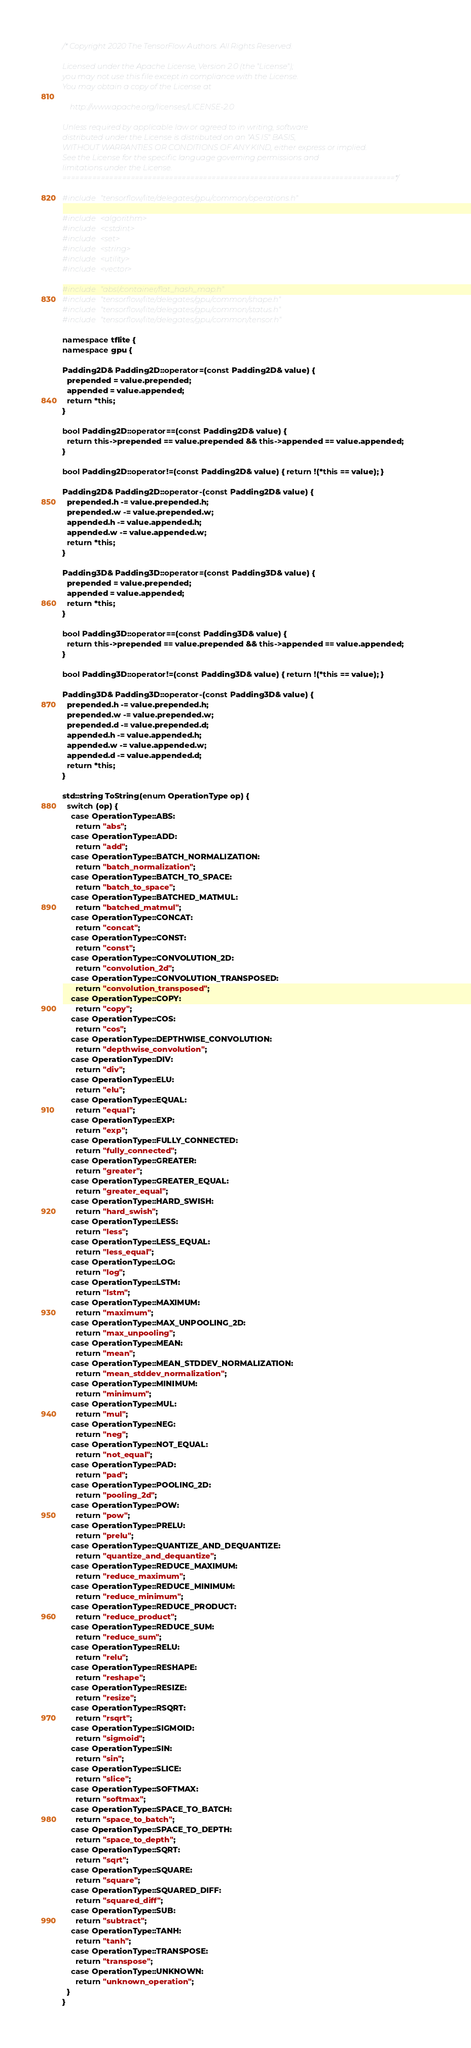Convert code to text. <code><loc_0><loc_0><loc_500><loc_500><_C++_>/* Copyright 2020 The TensorFlow Authors. All Rights Reserved.

Licensed under the Apache License, Version 2.0 (the "License");
you may not use this file except in compliance with the License.
You may obtain a copy of the License at

    http://www.apache.org/licenses/LICENSE-2.0

Unless required by applicable law or agreed to in writing, software
distributed under the License is distributed on an "AS IS" BASIS,
WITHOUT WARRANTIES OR CONDITIONS OF ANY KIND, either express or implied.
See the License for the specific language governing permissions and
limitations under the License.
==============================================================================*/

#include "tensorflow/lite/delegates/gpu/common/operations.h"

#include <algorithm>
#include <cstdint>
#include <set>
#include <string>
#include <utility>
#include <vector>

#include "absl/container/flat_hash_map.h"
#include "tensorflow/lite/delegates/gpu/common/shape.h"
#include "tensorflow/lite/delegates/gpu/common/status.h"
#include "tensorflow/lite/delegates/gpu/common/tensor.h"

namespace tflite {
namespace gpu {

Padding2D& Padding2D::operator=(const Padding2D& value) {
  prepended = value.prepended;
  appended = value.appended;
  return *this;
}

bool Padding2D::operator==(const Padding2D& value) {
  return this->prepended == value.prepended && this->appended == value.appended;
}

bool Padding2D::operator!=(const Padding2D& value) { return !(*this == value); }

Padding2D& Padding2D::operator-(const Padding2D& value) {
  prepended.h -= value.prepended.h;
  prepended.w -= value.prepended.w;
  appended.h -= value.appended.h;
  appended.w -= value.appended.w;
  return *this;
}

Padding3D& Padding3D::operator=(const Padding3D& value) {
  prepended = value.prepended;
  appended = value.appended;
  return *this;
}

bool Padding3D::operator==(const Padding3D& value) {
  return this->prepended == value.prepended && this->appended == value.appended;
}

bool Padding3D::operator!=(const Padding3D& value) { return !(*this == value); }

Padding3D& Padding3D::operator-(const Padding3D& value) {
  prepended.h -= value.prepended.h;
  prepended.w -= value.prepended.w;
  prepended.d -= value.prepended.d;
  appended.h -= value.appended.h;
  appended.w -= value.appended.w;
  appended.d -= value.appended.d;
  return *this;
}

std::string ToString(enum OperationType op) {
  switch (op) {
    case OperationType::ABS:
      return "abs";
    case OperationType::ADD:
      return "add";
    case OperationType::BATCH_NORMALIZATION:
      return "batch_normalization";
    case OperationType::BATCH_TO_SPACE:
      return "batch_to_space";
    case OperationType::BATCHED_MATMUL:
      return "batched_matmul";
    case OperationType::CONCAT:
      return "concat";
    case OperationType::CONST:
      return "const";
    case OperationType::CONVOLUTION_2D:
      return "convolution_2d";
    case OperationType::CONVOLUTION_TRANSPOSED:
      return "convolution_transposed";
    case OperationType::COPY:
      return "copy";
    case OperationType::COS:
      return "cos";
    case OperationType::DEPTHWISE_CONVOLUTION:
      return "depthwise_convolution";
    case OperationType::DIV:
      return "div";
    case OperationType::ELU:
      return "elu";
    case OperationType::EQUAL:
      return "equal";
    case OperationType::EXP:
      return "exp";
    case OperationType::FULLY_CONNECTED:
      return "fully_connected";
    case OperationType::GREATER:
      return "greater";
    case OperationType::GREATER_EQUAL:
      return "greater_equal";
    case OperationType::HARD_SWISH:
      return "hard_swish";
    case OperationType::LESS:
      return "less";
    case OperationType::LESS_EQUAL:
      return "less_equal";
    case OperationType::LOG:
      return "log";
    case OperationType::LSTM:
      return "lstm";
    case OperationType::MAXIMUM:
      return "maximum";
    case OperationType::MAX_UNPOOLING_2D:
      return "max_unpooling";
    case OperationType::MEAN:
      return "mean";
    case OperationType::MEAN_STDDEV_NORMALIZATION:
      return "mean_stddev_normalization";
    case OperationType::MINIMUM:
      return "minimum";
    case OperationType::MUL:
      return "mul";
    case OperationType::NEG:
      return "neg";
    case OperationType::NOT_EQUAL:
      return "not_equal";
    case OperationType::PAD:
      return "pad";
    case OperationType::POOLING_2D:
      return "pooling_2d";
    case OperationType::POW:
      return "pow";
    case OperationType::PRELU:
      return "prelu";
    case OperationType::QUANTIZE_AND_DEQUANTIZE:
      return "quantize_and_dequantize";
    case OperationType::REDUCE_MAXIMUM:
      return "reduce_maximum";
    case OperationType::REDUCE_MINIMUM:
      return "reduce_minimum";
    case OperationType::REDUCE_PRODUCT:
      return "reduce_product";
    case OperationType::REDUCE_SUM:
      return "reduce_sum";
    case OperationType::RELU:
      return "relu";
    case OperationType::RESHAPE:
      return "reshape";
    case OperationType::RESIZE:
      return "resize";
    case OperationType::RSQRT:
      return "rsqrt";
    case OperationType::SIGMOID:
      return "sigmoid";
    case OperationType::SIN:
      return "sin";
    case OperationType::SLICE:
      return "slice";
    case OperationType::SOFTMAX:
      return "softmax";
    case OperationType::SPACE_TO_BATCH:
      return "space_to_batch";
    case OperationType::SPACE_TO_DEPTH:
      return "space_to_depth";
    case OperationType::SQRT:
      return "sqrt";
    case OperationType::SQUARE:
      return "square";
    case OperationType::SQUARED_DIFF:
      return "squared_diff";
    case OperationType::SUB:
      return "subtract";
    case OperationType::TANH:
      return "tanh";
    case OperationType::TRANSPOSE:
      return "transpose";
    case OperationType::UNKNOWN:
      return "unknown_operation";
  }
}
</code> 